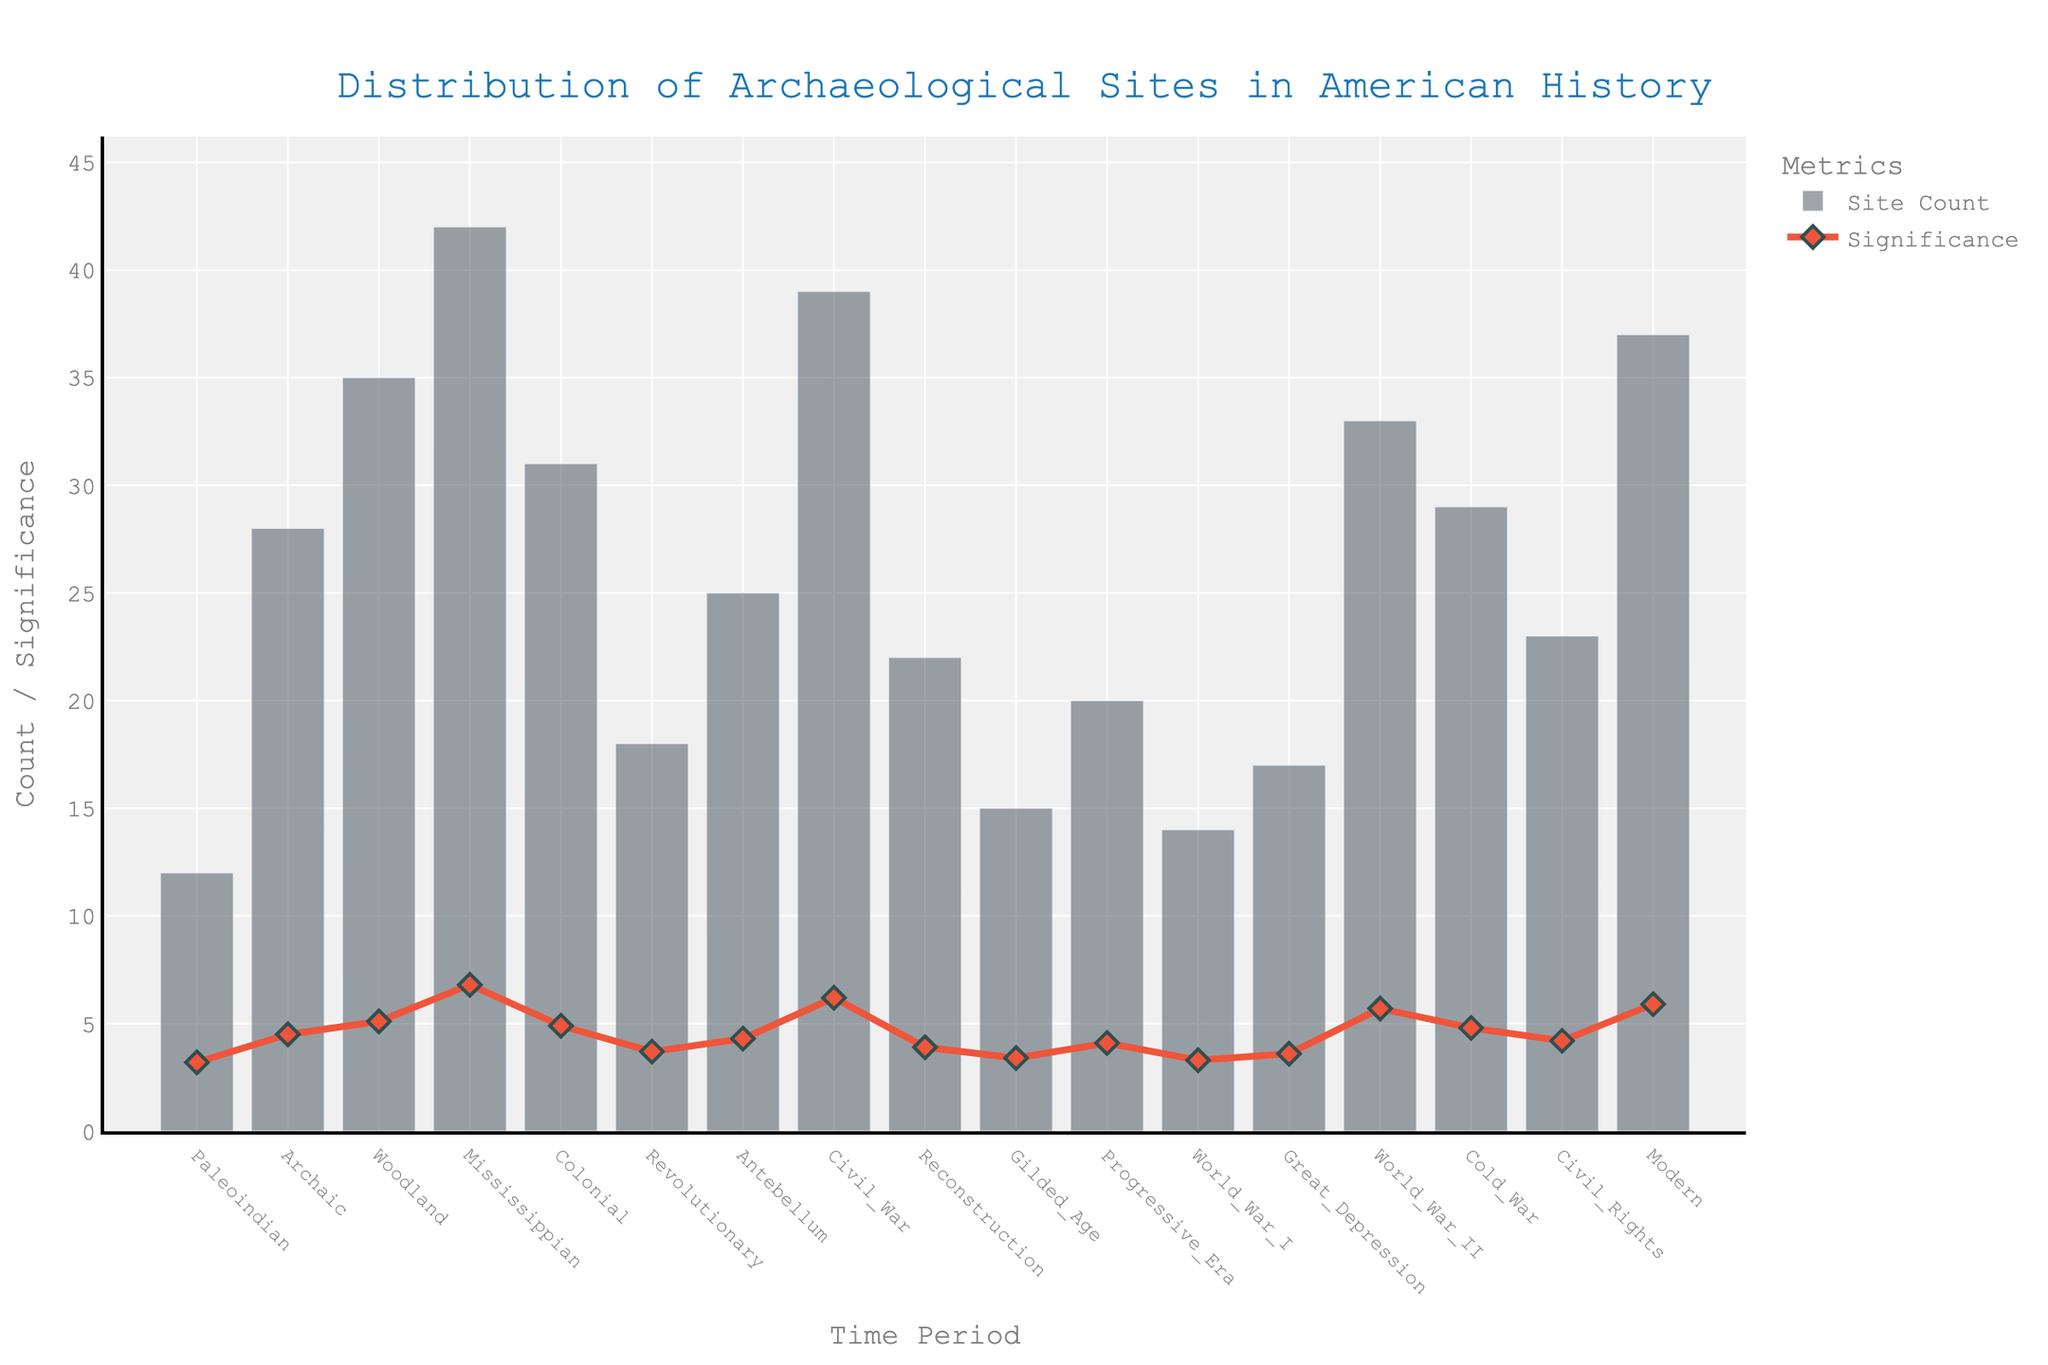What's the title of the figure? The title is located at the top of the figure and usually describes the overall content.
Answer: Distribution of Archaeological Sites in American History What time period has the highest number of archaeological sites? Look at the bar heights and identify the one that is the tallest.
Answer: Mississippian Which time period shows the highest significance value? Identify the time period with the highest point on the significance line.
Answer: Mississippian How many archaeological sites were found during the Revolutionary period? Find the bar labeled "Revolutionary" and read its height.
Answer: 18 What is the difference in the number of archaeological sites between the Mississippian and Colonial periods? Subtract the Site Count of the Colonial period from that of the Mississippian period: 42 - 31.
Answer: 11 Which time period has a greater significance value, Progressive Era or Gilded Age? Compare the heights of the significance points for Progressive Era and Gilded Age.
Answer: Progressive Era What is the average significance value across all time periods? Add all the significance values and divide by the number of time periods: (3.2 + 4.5 + 5.1 + 6.8 + 4.9 + 3.7 + 4.3 + 6.2 + 3.9 + 3.4 + 4.1 + 3.3 + 3.6 + 5.7 + 4.8 + 4.2 + 5.9) / 17.
Answer: 4.57 Which period has a higher count, Civil War or World War II? Compare the bar heights for Civil War and World War II.
Answer: Civil War What is the significance value for the Modern period? Look at the significance line and identify the point corresponding to the Modern period.
Answer: 5.9 Which time period has the lowest number of archaeological sites? Find the bar labeled "Paleoindian" and confirm it is the shortest.
Answer: Paleoindian 